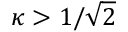<formula> <loc_0><loc_0><loc_500><loc_500>\kappa > 1 / { \sqrt { 2 } }</formula> 